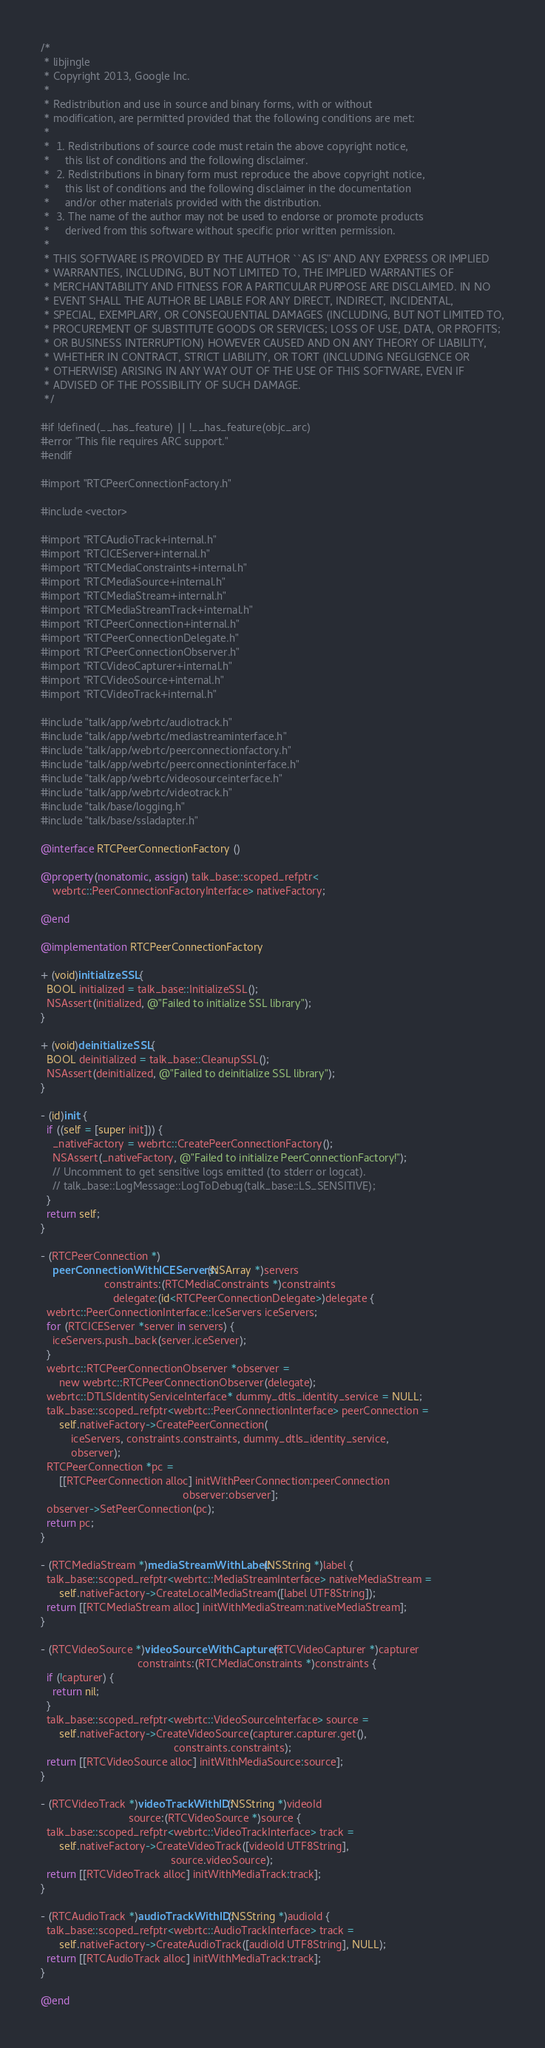<code> <loc_0><loc_0><loc_500><loc_500><_ObjectiveC_>/*
 * libjingle
 * Copyright 2013, Google Inc.
 *
 * Redistribution and use in source and binary forms, with or without
 * modification, are permitted provided that the following conditions are met:
 *
 *  1. Redistributions of source code must retain the above copyright notice,
 *     this list of conditions and the following disclaimer.
 *  2. Redistributions in binary form must reproduce the above copyright notice,
 *     this list of conditions and the following disclaimer in the documentation
 *     and/or other materials provided with the distribution.
 *  3. The name of the author may not be used to endorse or promote products
 *     derived from this software without specific prior written permission.
 *
 * THIS SOFTWARE IS PROVIDED BY THE AUTHOR ``AS IS'' AND ANY EXPRESS OR IMPLIED
 * WARRANTIES, INCLUDING, BUT NOT LIMITED TO, THE IMPLIED WARRANTIES OF
 * MERCHANTABILITY AND FITNESS FOR A PARTICULAR PURPOSE ARE DISCLAIMED. IN NO
 * EVENT SHALL THE AUTHOR BE LIABLE FOR ANY DIRECT, INDIRECT, INCIDENTAL,
 * SPECIAL, EXEMPLARY, OR CONSEQUENTIAL DAMAGES (INCLUDING, BUT NOT LIMITED TO,
 * PROCUREMENT OF SUBSTITUTE GOODS OR SERVICES; LOSS OF USE, DATA, OR PROFITS;
 * OR BUSINESS INTERRUPTION) HOWEVER CAUSED AND ON ANY THEORY OF LIABILITY,
 * WHETHER IN CONTRACT, STRICT LIABILITY, OR TORT (INCLUDING NEGLIGENCE OR
 * OTHERWISE) ARISING IN ANY WAY OUT OF THE USE OF THIS SOFTWARE, EVEN IF
 * ADVISED OF THE POSSIBILITY OF SUCH DAMAGE.
 */

#if !defined(__has_feature) || !__has_feature(objc_arc)
#error "This file requires ARC support."
#endif

#import "RTCPeerConnectionFactory.h"

#include <vector>

#import "RTCAudioTrack+internal.h"
#import "RTCICEServer+internal.h"
#import "RTCMediaConstraints+internal.h"
#import "RTCMediaSource+internal.h"
#import "RTCMediaStream+internal.h"
#import "RTCMediaStreamTrack+internal.h"
#import "RTCPeerConnection+internal.h"
#import "RTCPeerConnectionDelegate.h"
#import "RTCPeerConnectionObserver.h"
#import "RTCVideoCapturer+internal.h"
#import "RTCVideoSource+internal.h"
#import "RTCVideoTrack+internal.h"

#include "talk/app/webrtc/audiotrack.h"
#include "talk/app/webrtc/mediastreaminterface.h"
#include "talk/app/webrtc/peerconnectionfactory.h"
#include "talk/app/webrtc/peerconnectioninterface.h"
#include "talk/app/webrtc/videosourceinterface.h"
#include "talk/app/webrtc/videotrack.h"
#include "talk/base/logging.h"
#include "talk/base/ssladapter.h"

@interface RTCPeerConnectionFactory ()

@property(nonatomic, assign) talk_base::scoped_refptr<
    webrtc::PeerConnectionFactoryInterface> nativeFactory;

@end

@implementation RTCPeerConnectionFactory

+ (void)initializeSSL {
  BOOL initialized = talk_base::InitializeSSL();
  NSAssert(initialized, @"Failed to initialize SSL library");
}

+ (void)deinitializeSSL {
  BOOL deinitialized = talk_base::CleanupSSL();
  NSAssert(deinitialized, @"Failed to deinitialize SSL library");
}

- (id)init {
  if ((self = [super init])) {
    _nativeFactory = webrtc::CreatePeerConnectionFactory();
    NSAssert(_nativeFactory, @"Failed to initialize PeerConnectionFactory!");
    // Uncomment to get sensitive logs emitted (to stderr or logcat).
    // talk_base::LogMessage::LogToDebug(talk_base::LS_SENSITIVE);
  }
  return self;
}

- (RTCPeerConnection *)
    peerConnectionWithICEServers:(NSArray *)servers
                     constraints:(RTCMediaConstraints *)constraints
                        delegate:(id<RTCPeerConnectionDelegate>)delegate {
  webrtc::PeerConnectionInterface::IceServers iceServers;
  for (RTCICEServer *server in servers) {
    iceServers.push_back(server.iceServer);
  }
  webrtc::RTCPeerConnectionObserver *observer =
      new webrtc::RTCPeerConnectionObserver(delegate);
  webrtc::DTLSIdentityServiceInterface* dummy_dtls_identity_service = NULL;
  talk_base::scoped_refptr<webrtc::PeerConnectionInterface> peerConnection =
      self.nativeFactory->CreatePeerConnection(
          iceServers, constraints.constraints, dummy_dtls_identity_service,
          observer);
  RTCPeerConnection *pc =
      [[RTCPeerConnection alloc] initWithPeerConnection:peerConnection
                                               observer:observer];
  observer->SetPeerConnection(pc);
  return pc;
}

- (RTCMediaStream *)mediaStreamWithLabel:(NSString *)label {
  talk_base::scoped_refptr<webrtc::MediaStreamInterface> nativeMediaStream =
      self.nativeFactory->CreateLocalMediaStream([label UTF8String]);
  return [[RTCMediaStream alloc] initWithMediaStream:nativeMediaStream];
}

- (RTCVideoSource *)videoSourceWithCapturer:(RTCVideoCapturer *)capturer
                                constraints:(RTCMediaConstraints *)constraints {
  if (!capturer) {
    return nil;
  }
  talk_base::scoped_refptr<webrtc::VideoSourceInterface> source =
      self.nativeFactory->CreateVideoSource(capturer.capturer.get(),
                                            constraints.constraints);
  return [[RTCVideoSource alloc] initWithMediaSource:source];
}

- (RTCVideoTrack *)videoTrackWithID:(NSString *)videoId
                             source:(RTCVideoSource *)source {
  talk_base::scoped_refptr<webrtc::VideoTrackInterface> track =
      self.nativeFactory->CreateVideoTrack([videoId UTF8String],
                                           source.videoSource);
  return [[RTCVideoTrack alloc] initWithMediaTrack:track];
}

- (RTCAudioTrack *)audioTrackWithID:(NSString *)audioId {
  talk_base::scoped_refptr<webrtc::AudioTrackInterface> track =
      self.nativeFactory->CreateAudioTrack([audioId UTF8String], NULL);
  return [[RTCAudioTrack alloc] initWithMediaTrack:track];
}

@end
</code> 